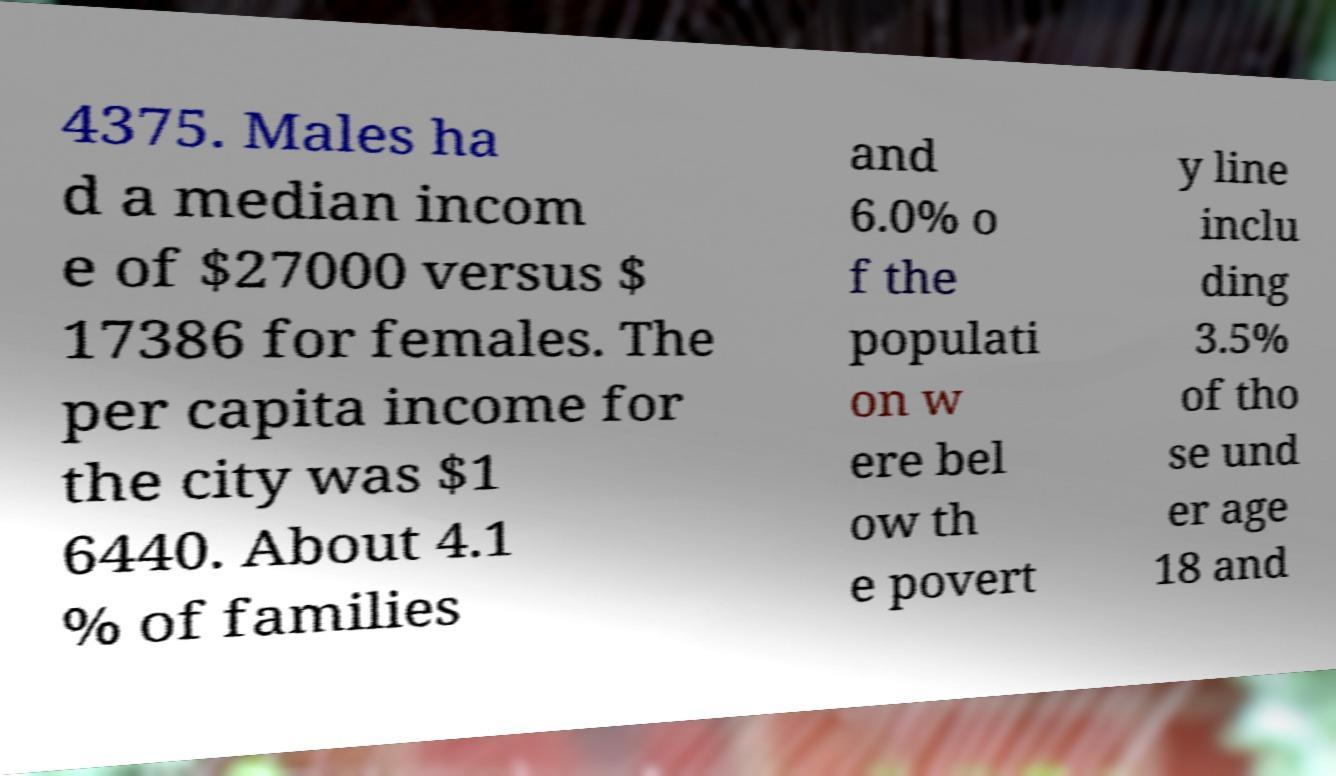There's text embedded in this image that I need extracted. Can you transcribe it verbatim? 4375. Males ha d a median incom e of $27000 versus $ 17386 for females. The per capita income for the city was $1 6440. About 4.1 % of families and 6.0% o f the populati on w ere bel ow th e povert y line inclu ding 3.5% of tho se und er age 18 and 